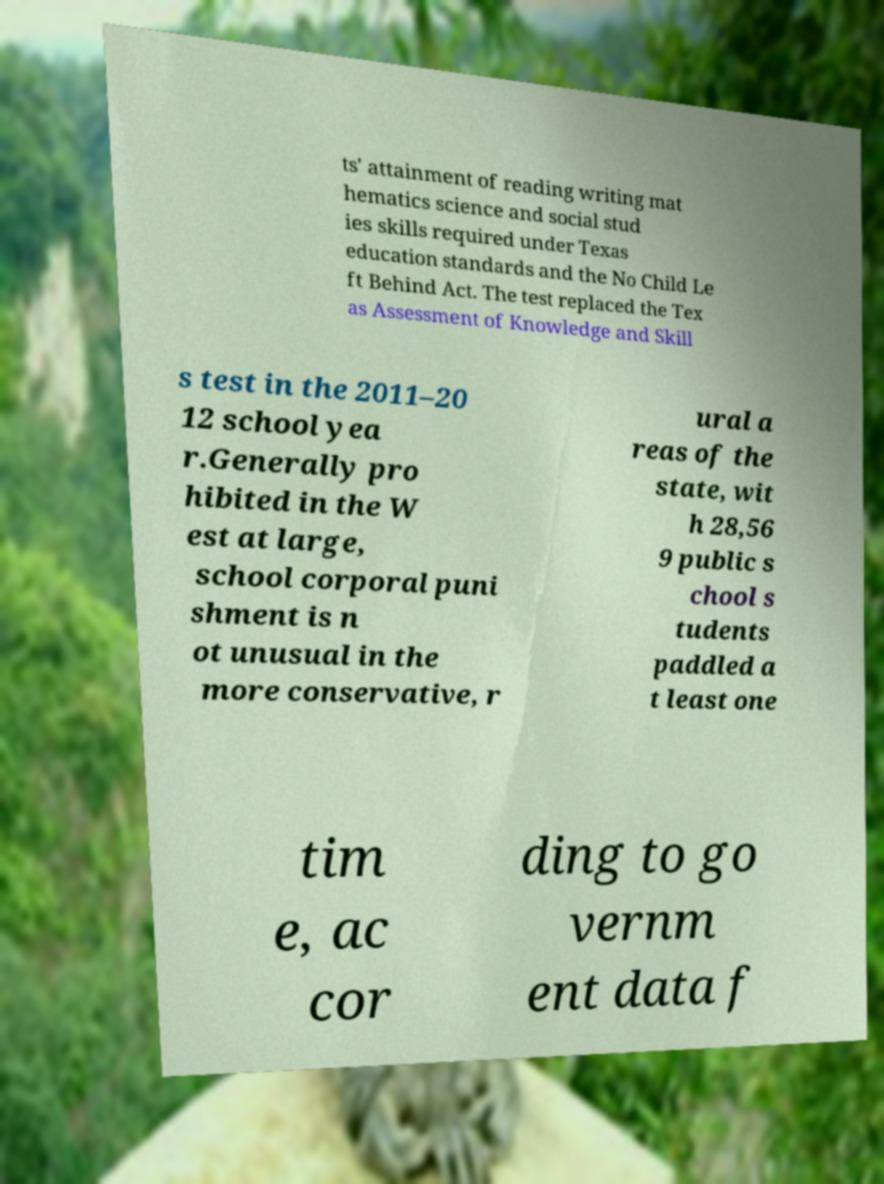For documentation purposes, I need the text within this image transcribed. Could you provide that? ts' attainment of reading writing mat hematics science and social stud ies skills required under Texas education standards and the No Child Le ft Behind Act. The test replaced the Tex as Assessment of Knowledge and Skill s test in the 2011–20 12 school yea r.Generally pro hibited in the W est at large, school corporal puni shment is n ot unusual in the more conservative, r ural a reas of the state, wit h 28,56 9 public s chool s tudents paddled a t least one tim e, ac cor ding to go vernm ent data f 